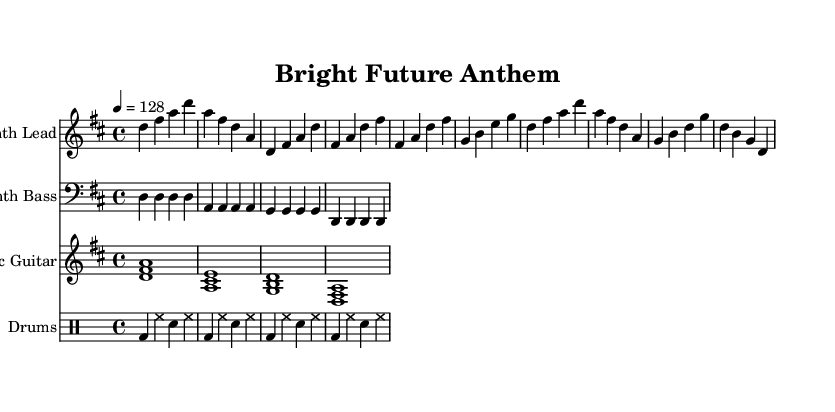What is the key signature of this music? The key signature is D major, which has two sharps represented by the F# and C#.
Answer: D major What is the time signature of this music? The time signature is 4/4, which indicates each measure consists of four beats.
Answer: 4/4 What is the tempo marking of this music? The tempo marking is 128, indicating the beats per minute.
Answer: 128 What is the main instrument used for the lead melody? The lead melody is played by the synth lead, which is prominent in electronic music.
Answer: Synth Lead How many measures are in the chorus section? The chorus section consists of four measures based on the given musical notation.
Answer: 4 What type of musical form does this piece follow in its structure? The piece follows a verse-chorus form, which is common in electronic music, highlighting youthful themes.
Answer: Verse-chorus What is the rhythmic approach of the drum part? The drum part uses a steady backbeat with bass and snare accents, typical of electronic rock.
Answer: Steady backbeat 